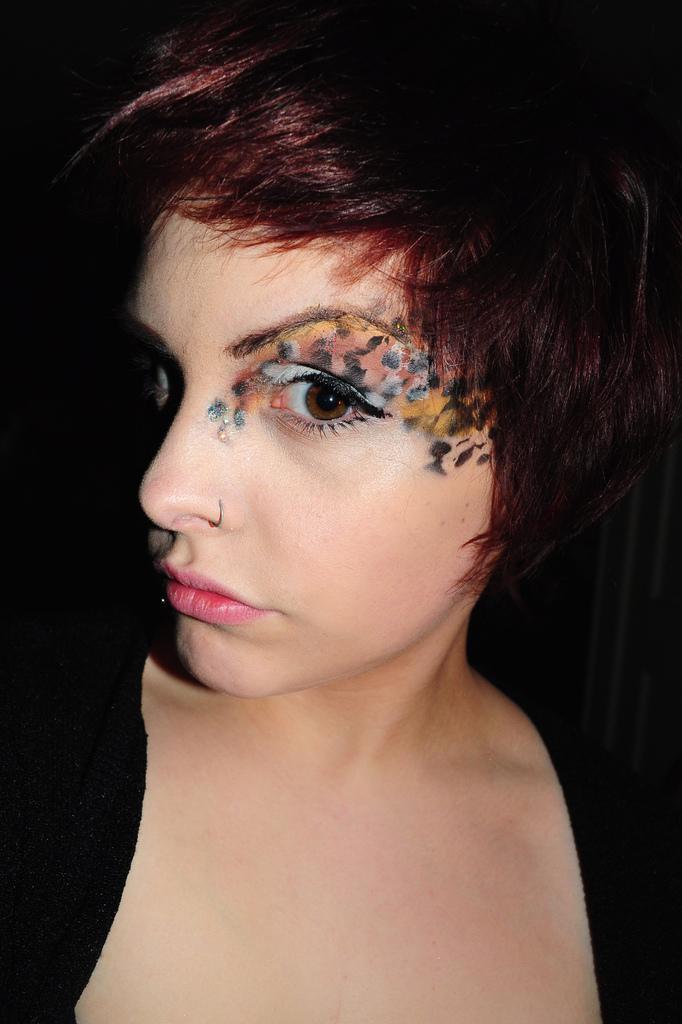Could you give a brief overview of what you see in this image? In this image, we can see a woman is black dress is seeing and wearing a nose ring. 